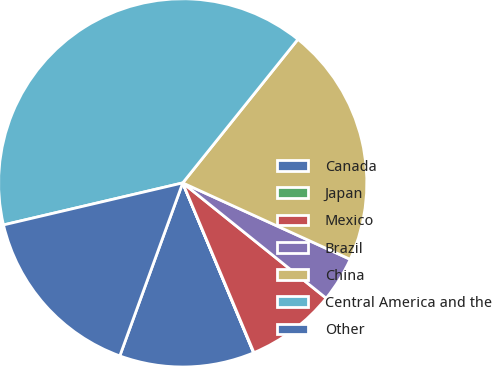Convert chart to OTSL. <chart><loc_0><loc_0><loc_500><loc_500><pie_chart><fcel>Canada<fcel>Japan<fcel>Mexico<fcel>Brazil<fcel>China<fcel>Central America and the<fcel>Other<nl><fcel>11.84%<fcel>0.03%<fcel>7.9%<fcel>3.96%<fcel>21.05%<fcel>39.42%<fcel>15.78%<nl></chart> 